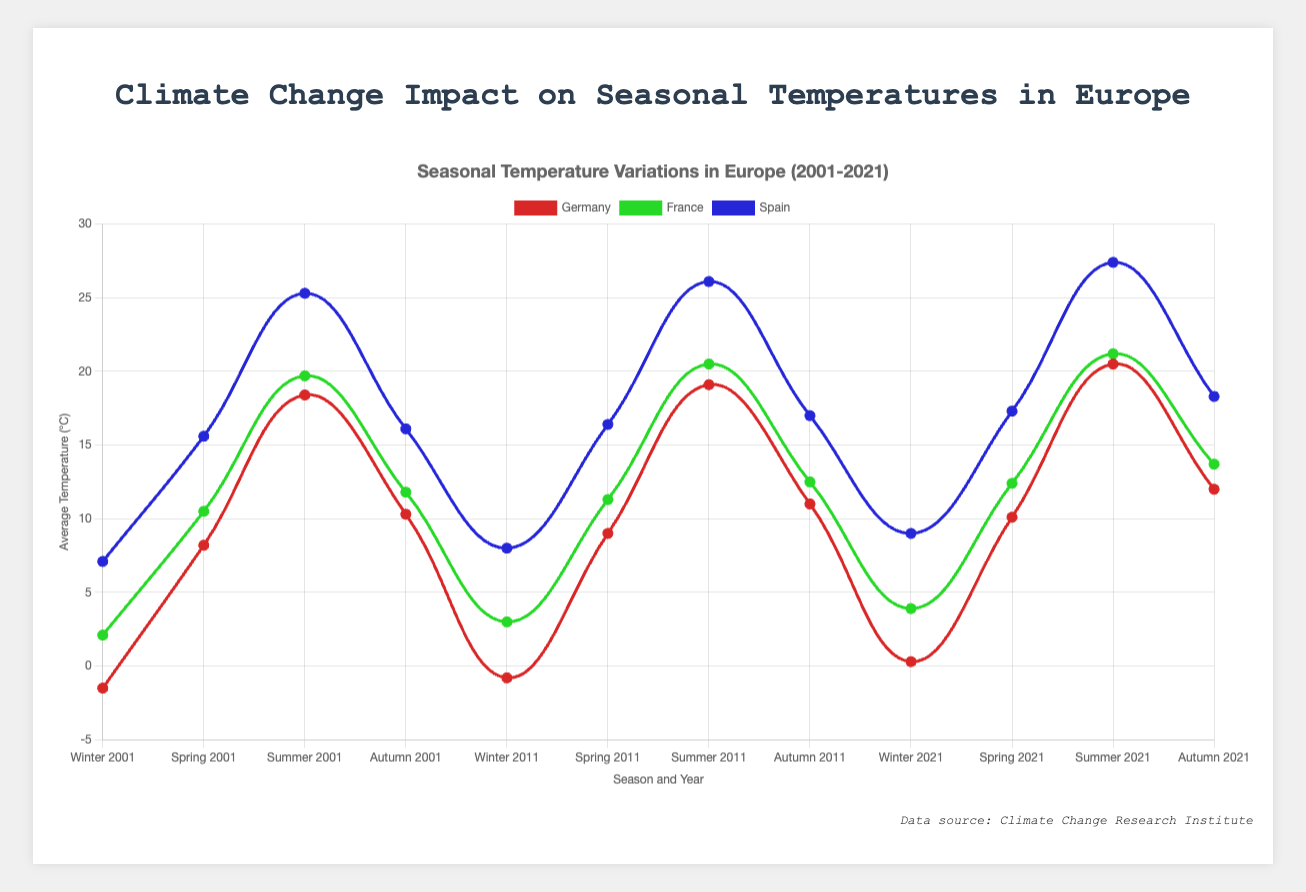What is the general trend in the average temperature of Germany during Winter from 2001 to 2021? The chart shows a clear increase in the average temperature of Germany during Winter from -1.5°C in 2001 to -0.8°C in 2011 and then to 0.3°C in 2021.
Answer: Increasing Comparing Germany and France, which country had a higher average temperature during Summer in 2021? From the chart, the average temperature for Germany in Summer 2021 is 20.5°C, while for France, it is 21.2°C. Therefore, France had a higher average temperature.
Answer: France During which season did Spain experience the highest average temperature in 2011? By analyzing the data points in the chart for Spain in 2011, we can see that Summer has the highest temperature, with 26.1°C.
Answer: Summer How did the average temperature for Spring in France change from 2001 to 2021? Looking at the Spring data points for France, the average temperature increased from 10.5°C in 2001 to 12.4°C in 2021.
Answer: Increased What's the difference in the average temperature between Autumn and Winter in Germany in 2021? In 2021, Germany’s average temperature in Autumn was 12.0°C and in Winter was 0.3°C. The difference is calculated as 12.0°C - 0.3°C = 11.7°C.
Answer: 11.7°C Which year showed a larger increment in the average summer temperature for Spain from the previous measured year, 2001 to 2011 or 2011 to 2021? In 2001, the average summer temperature in Spain was 25.3°C, and it increased to 26.1°C in 2011, indicating an increment of 0.8°C. From 2011 to 2021, it increased from 26.1°C to 27.4°C, an increment of 1.3°C. Therefore, the increment was larger from 2011 to 2021.
Answer: 2011 to 2021 On average, which country had the highest average temperature during Winter over the years 2001, 2011, and 2021? By looking at the Winter temperatures for all three countries, Spain has temperatures of 7.1°C in 2001, 8.0°C in 2011, and 9.0°C in 2021, which are higher than those of Germany and France in these years.
Answer: Spain Considering the visuals, what is the color representing the line for Germany? Observing the chart, the line representing Germany is colored in blue.
Answer: Blue Which season and year showed the highest temperature recorded in Germany according to the chart? The highest recorded temperature for Germany, as evident from the chart, is in Summer 2021, with an average temperature of 20.5°C.
Answer: Summer 2021 What’s the temperature difference between Summer in France and Spring in Spain in 2021? In 2021, the average temperature in Summer for France is 21.2°C, and in Spring for Spain, it is 17.3°C. The difference is calculated as 21.2°C - 17.3°C = 3.9°C.
Answer: 3.9°C 